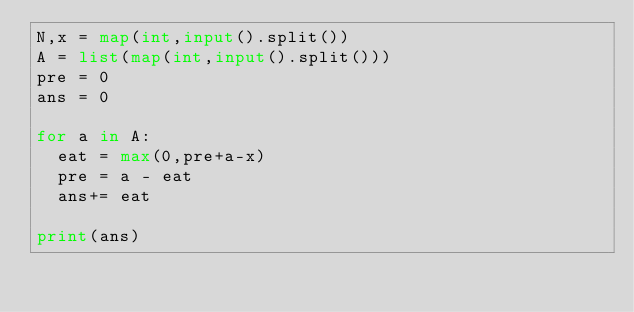<code> <loc_0><loc_0><loc_500><loc_500><_Python_>N,x = map(int,input().split())
A = list(map(int,input().split()))
pre = 0
ans = 0

for a in A:
  eat = max(0,pre+a-x)
  pre = a - eat
  ans+= eat

print(ans)</code> 